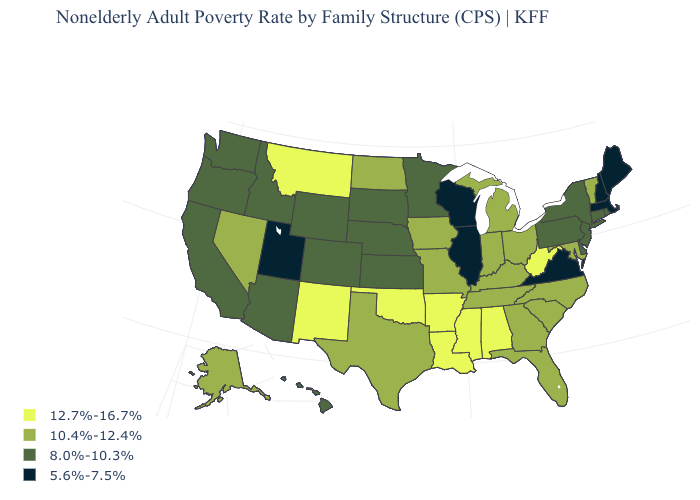Name the states that have a value in the range 8.0%-10.3%?
Write a very short answer. Arizona, California, Colorado, Connecticut, Delaware, Hawaii, Idaho, Kansas, Minnesota, Nebraska, New Jersey, New York, Oregon, Pennsylvania, Rhode Island, South Dakota, Washington, Wyoming. Name the states that have a value in the range 12.7%-16.7%?
Give a very brief answer. Alabama, Arkansas, Louisiana, Mississippi, Montana, New Mexico, Oklahoma, West Virginia. What is the highest value in the USA?
Quick response, please. 12.7%-16.7%. Which states have the highest value in the USA?
Concise answer only. Alabama, Arkansas, Louisiana, Mississippi, Montana, New Mexico, Oklahoma, West Virginia. What is the value of South Carolina?
Write a very short answer. 10.4%-12.4%. What is the highest value in the USA?
Short answer required. 12.7%-16.7%. Which states have the highest value in the USA?
Concise answer only. Alabama, Arkansas, Louisiana, Mississippi, Montana, New Mexico, Oklahoma, West Virginia. Name the states that have a value in the range 12.7%-16.7%?
Be succinct. Alabama, Arkansas, Louisiana, Mississippi, Montana, New Mexico, Oklahoma, West Virginia. Name the states that have a value in the range 10.4%-12.4%?
Give a very brief answer. Alaska, Florida, Georgia, Indiana, Iowa, Kentucky, Maryland, Michigan, Missouri, Nevada, North Carolina, North Dakota, Ohio, South Carolina, Tennessee, Texas, Vermont. Does Hawaii have a higher value than Minnesota?
Quick response, please. No. Does Iowa have the same value as Mississippi?
Be succinct. No. Which states have the lowest value in the USA?
Keep it brief. Illinois, Maine, Massachusetts, New Hampshire, Utah, Virginia, Wisconsin. What is the value of Wisconsin?
Write a very short answer. 5.6%-7.5%. Name the states that have a value in the range 12.7%-16.7%?
Answer briefly. Alabama, Arkansas, Louisiana, Mississippi, Montana, New Mexico, Oklahoma, West Virginia. What is the highest value in states that border South Dakota?
Write a very short answer. 12.7%-16.7%. 